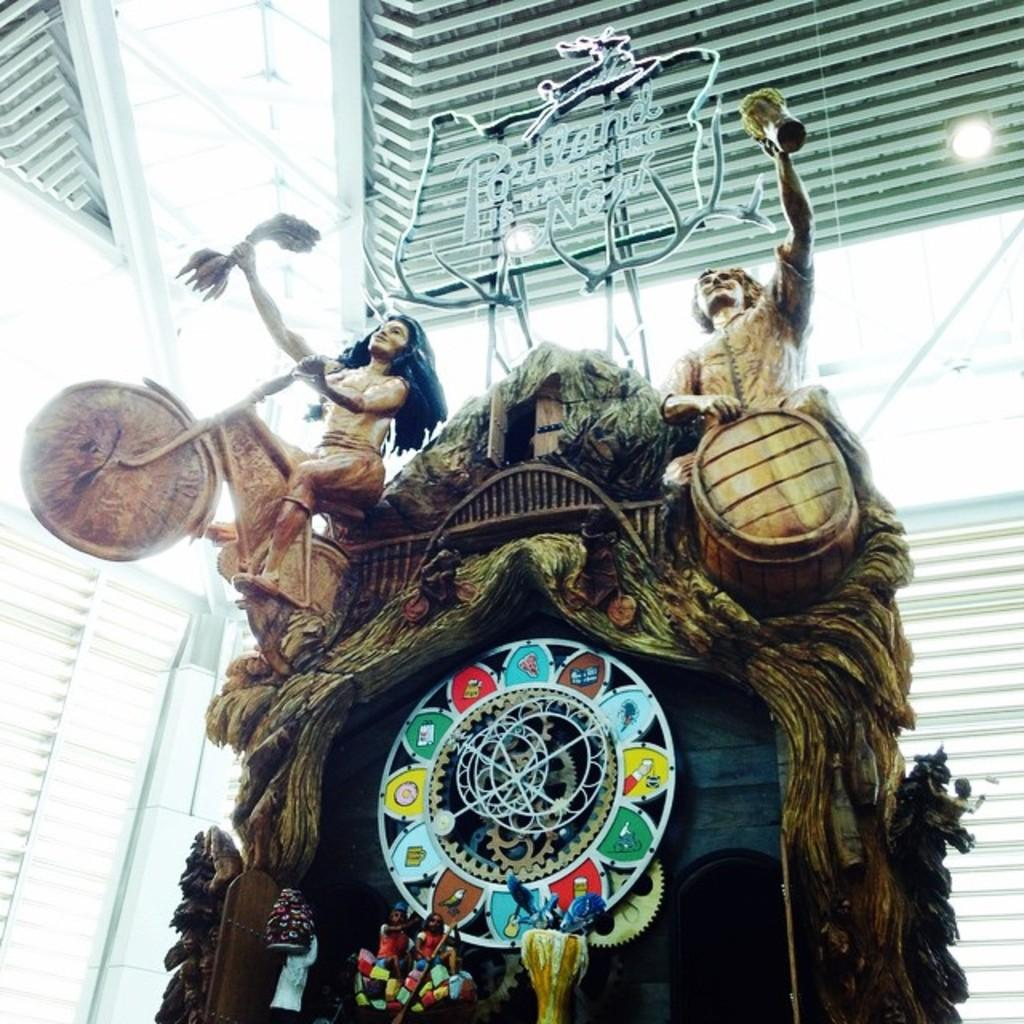What is present on the object in the image? There are statues on an object in the image. What can be seen in the background of the image? There are lights and a wall visible in the background of the image. What type of humor can be seen in the image? There is no humor present in the image; it features statues on an object and lights and a wall in the background. Can you tell me how many people are joining the statues in the image? There are no people present in the image, so it is not possible to determine how many might be joining the statues. 